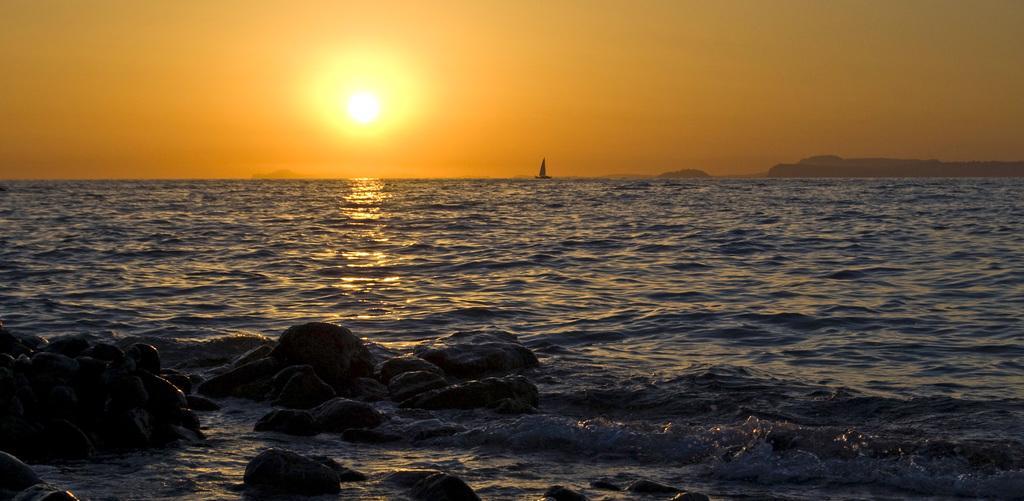How would you summarize this image in a sentence or two? In this image we can see the water and at the bottom of the image we can see some rocks and there is a boat on the water. We can see the mountains in the background and at the top we can see the sky with the sun. 